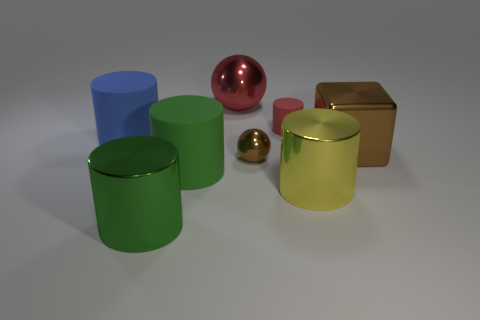Add 1 big things. How many objects exist? 9 Subtract all blue cylinders. How many cylinders are left? 4 Subtract all small red rubber cylinders. How many cylinders are left? 4 Subtract all spheres. How many objects are left? 6 Add 3 brown balls. How many brown balls are left? 4 Add 4 small shiny spheres. How many small shiny spheres exist? 5 Subtract 0 purple balls. How many objects are left? 8 Subtract 1 blocks. How many blocks are left? 0 Subtract all gray cylinders. Subtract all gray blocks. How many cylinders are left? 5 Subtract all green cylinders. How many blue blocks are left? 0 